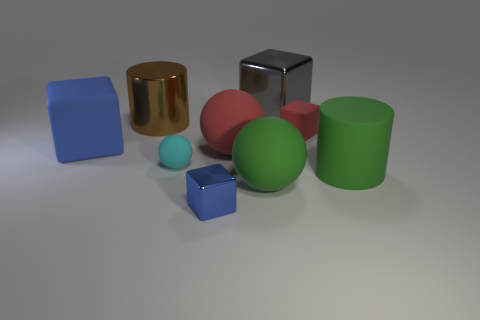Add 1 tiny green metal spheres. How many objects exist? 10 Subtract all cylinders. How many objects are left? 7 Subtract all big gray metal objects. Subtract all rubber blocks. How many objects are left? 6 Add 3 big cylinders. How many big cylinders are left? 5 Add 4 tiny cyan things. How many tiny cyan things exist? 5 Subtract 1 blue cubes. How many objects are left? 8 